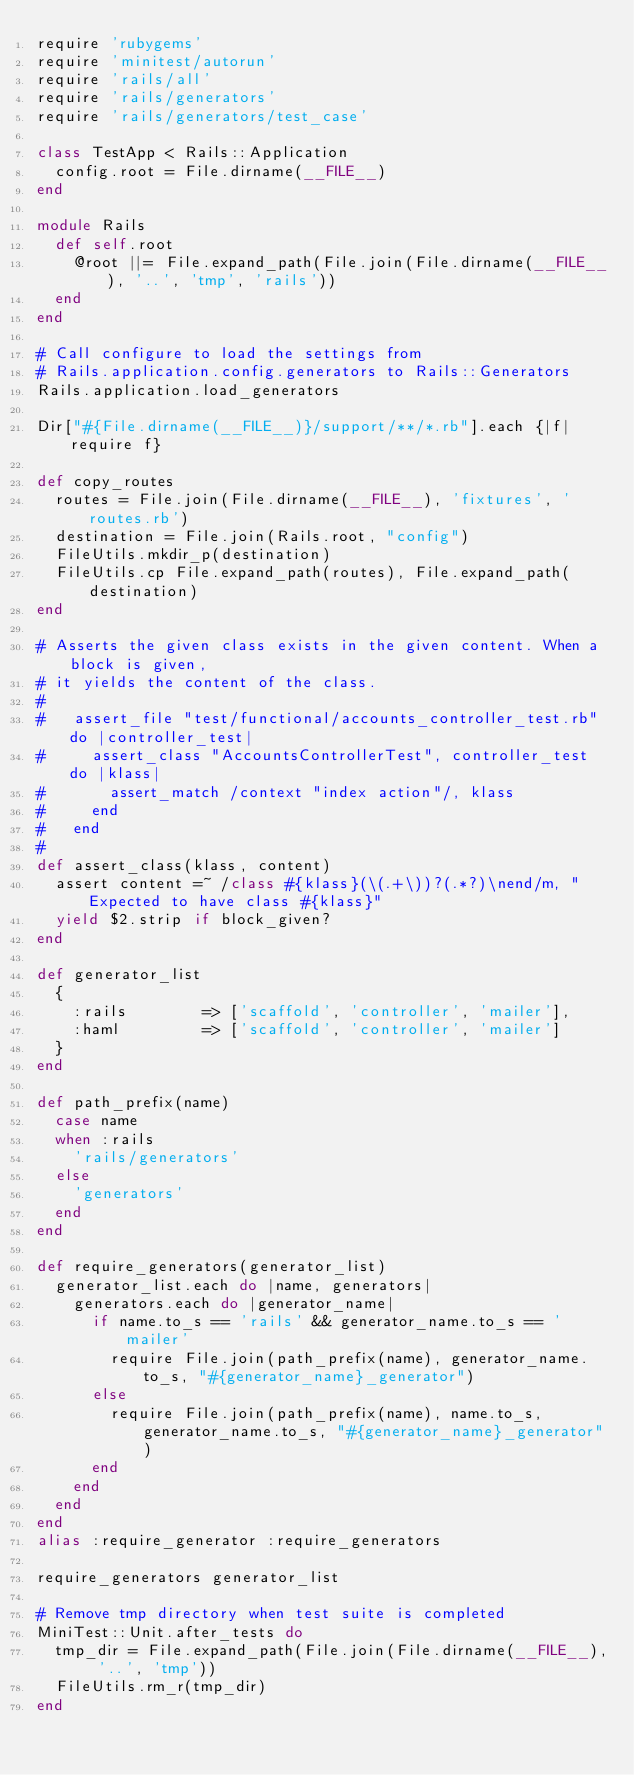Convert code to text. <code><loc_0><loc_0><loc_500><loc_500><_Ruby_>require 'rubygems'
require 'minitest/autorun'
require 'rails/all'
require 'rails/generators'
require 'rails/generators/test_case'

class TestApp < Rails::Application
  config.root = File.dirname(__FILE__)
end

module Rails
  def self.root
    @root ||= File.expand_path(File.join(File.dirname(__FILE__), '..', 'tmp', 'rails'))
  end
end

# Call configure to load the settings from
# Rails.application.config.generators to Rails::Generators
Rails.application.load_generators

Dir["#{File.dirname(__FILE__)}/support/**/*.rb"].each {|f| require f}

def copy_routes
  routes = File.join(File.dirname(__FILE__), 'fixtures', 'routes.rb')
  destination = File.join(Rails.root, "config")
  FileUtils.mkdir_p(destination)
  FileUtils.cp File.expand_path(routes), File.expand_path(destination)
end

# Asserts the given class exists in the given content. When a block is given,
# it yields the content of the class.
#
#   assert_file "test/functional/accounts_controller_test.rb" do |controller_test|
#     assert_class "AccountsControllerTest", controller_test do |klass|
#       assert_match /context "index action"/, klass
#     end
#   end
#
def assert_class(klass, content)
  assert content =~ /class #{klass}(\(.+\))?(.*?)\nend/m, "Expected to have class #{klass}"
  yield $2.strip if block_given?
end

def generator_list
  {
    :rails        => ['scaffold', 'controller', 'mailer'],
    :haml         => ['scaffold', 'controller', 'mailer']
  }
end

def path_prefix(name)
  case name
  when :rails
    'rails/generators'
  else
    'generators'
  end
end

def require_generators(generator_list)
  generator_list.each do |name, generators|
    generators.each do |generator_name|
      if name.to_s == 'rails' && generator_name.to_s == 'mailer'
        require File.join(path_prefix(name), generator_name.to_s, "#{generator_name}_generator")
      else
        require File.join(path_prefix(name), name.to_s, generator_name.to_s, "#{generator_name}_generator")
      end
    end
  end
end
alias :require_generator :require_generators

require_generators generator_list

# Remove tmp directory when test suite is completed
MiniTest::Unit.after_tests do
  tmp_dir = File.expand_path(File.join(File.dirname(__FILE__), '..', 'tmp'))
  FileUtils.rm_r(tmp_dir)
end
</code> 